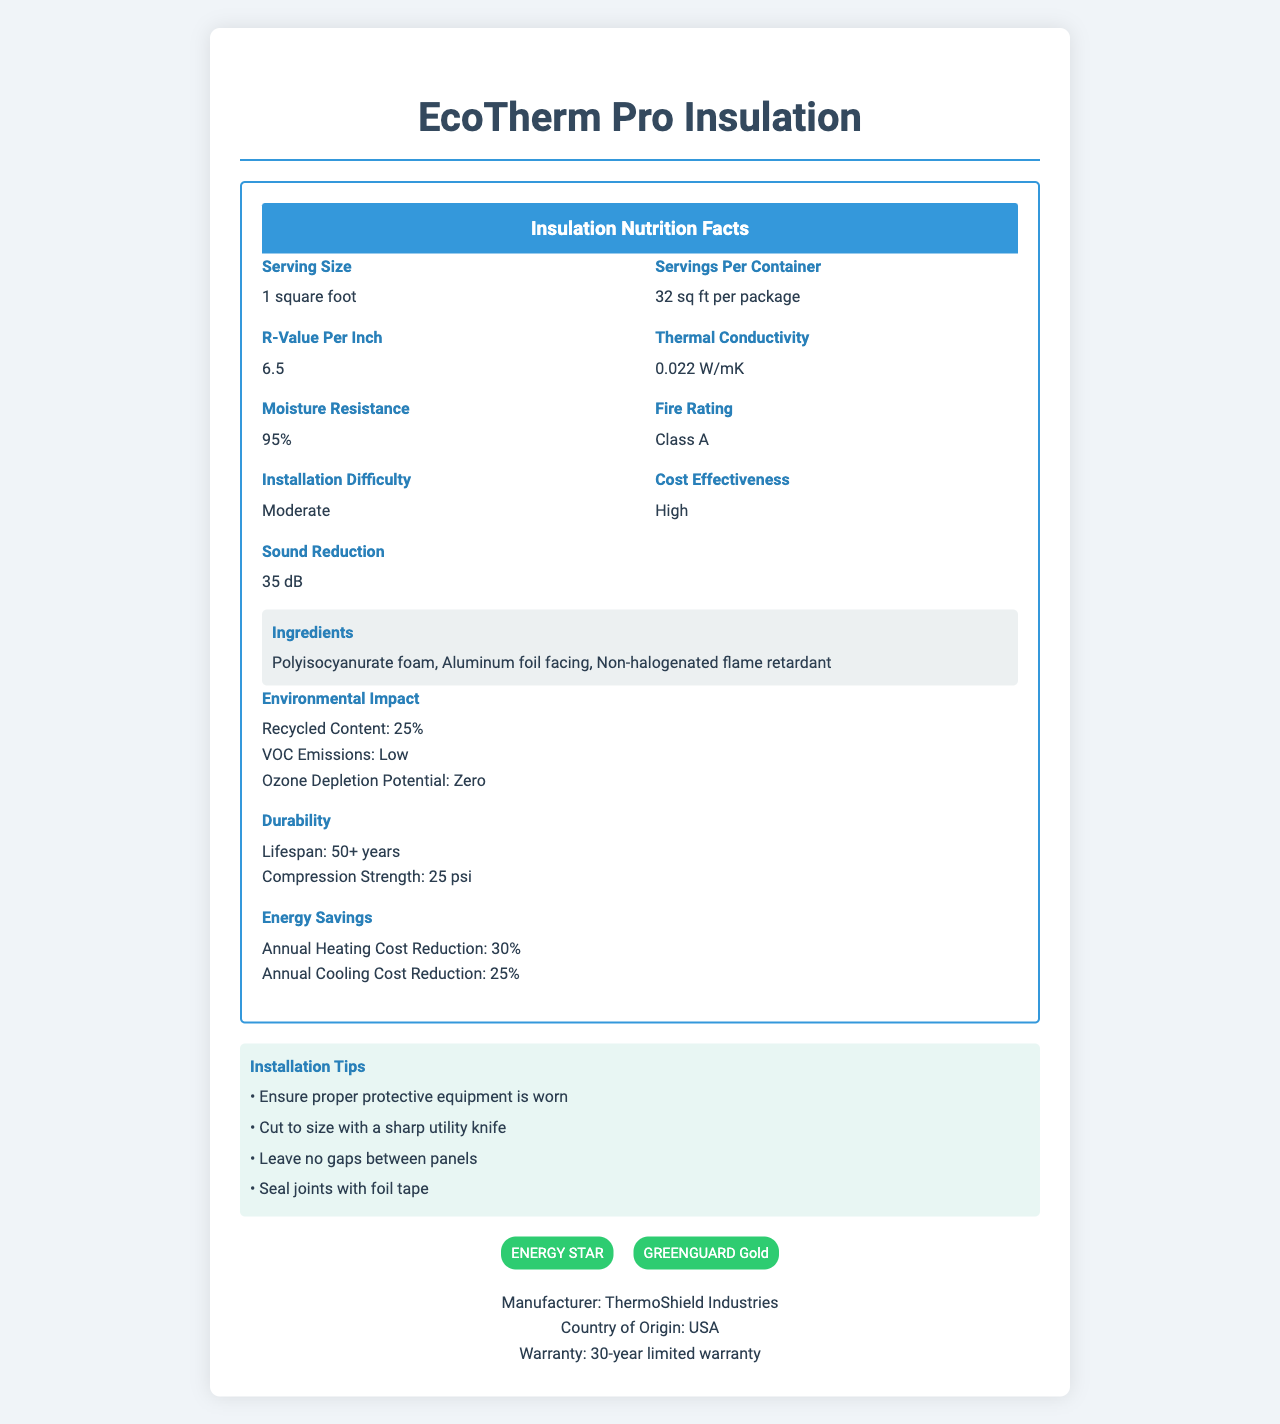what is the serving size for EcoTherm Pro Insulation? The serving size is listed as "1 square foot" in the "Insulation Nutrition Facts" section of the document.
Answer: 1 square foot how many servings per container does EcoTherm Pro Insulation have? The document indicates that there are "32 sq ft per package" under the "Servings Per Container" section.
Answer: 32 sq ft per package what is the R-value per inch of EcoTherm Pro Insulation? The R-value per inch is shown as "6.5" in the label section.
Answer: 6.5 what is the fire rating of EcoTherm Pro Insulation? The fire rating is listed as "Class A" in the label section of the document.
Answer: Class A what percentage of EcoTherm Pro Insulation is made from recycled content? The "Environmental Impact" section lists the recycled content as "25%".
Answer: 25% What is the thermal conductivity of EcoTherm Pro Insulation? The thermal conductivity is specified as "0.022 W/mK" in the label section.
Answer: 0.022 W/mK which ingredient in EcoTherm Pro Insulation acts as a flame retardant? A. Polyisocyanurate foam B. Aluminum foil facing C. Non-halogenated flame retardant The ingredient list includes "Non-halogenated flame retardant" which is specifically labeled as a flame retardant.
Answer: C. Non-halogenated flame retardant what is the moisture resistance percentage of EcoTherm Pro Insulation? The moisture resistance is shown as "95%" in the label section.
Answer: 95% What is the density of EcoTherm Pro Insulation? The document does not provide information about the density of the insulation material.
Answer: Cannot be determined what certifications does EcoTherm Pro Insulation have? A. ENERGY STAR B. GREENGUARD Gold C. UL Listed D. LEED Certified The document lists "ENERGY STAR" and "GREENGUARD Gold" as the certifications in the certifications section.
Answer: A. ENERGY STAR, B. GREENGUARD Gold does EcoTherm Pro Insulation have a Class B fire rating? (Yes/No) The fire rating for EcoTherm Pro Insulation is specified as "Class A", not Class B.
Answer: No describe the main idea of the EcoTherm Pro Insulation nutrition facts label The document provides a comprehensive overview of EcoTherm Pro Insulation's features, including its thermal and fire performance, materials used, installation tips, energy savings, certifications, and manufacturer details.
Answer: EcoTherm Pro Insulation is an energy-efficient insulation material highlighted by its high R-value, low thermal conductivity, significant moisture resistance, and Class A fire rating. It includes a combination of Polyisocyanurate foam, Aluminum foil facing, and a Non-halogenated flame retardant. It is cost-effective, moderately difficult to install, and has a positive environmental impact with 25% recycled content and zero ozone depletion potential. The product is durable, contributes to energy savings, and has certifications from ENERGY STAR and GREENGUARD Gold. who manufactures EcoTherm Pro Insulation? The manufacturer is listed as "ThermoShield Industries" at the bottom of the document.
Answer: ThermoShield Industries what are the installation tips for EcoTherm Pro Insulation? The "Installation Tips" section lists these specific instructions for proper installation of the insulation material.
Answer: Ensure proper protective equipment is worn, cut to size with a sharp utility knife, leave no gaps between panels, seal joints with foil tape 